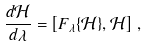<formula> <loc_0><loc_0><loc_500><loc_500>\frac { d \mathcal { H } } { d \lambda } = \left [ F _ { \lambda } \{ \mathcal { H } \} , \mathcal { H } \right ] \, ,</formula> 